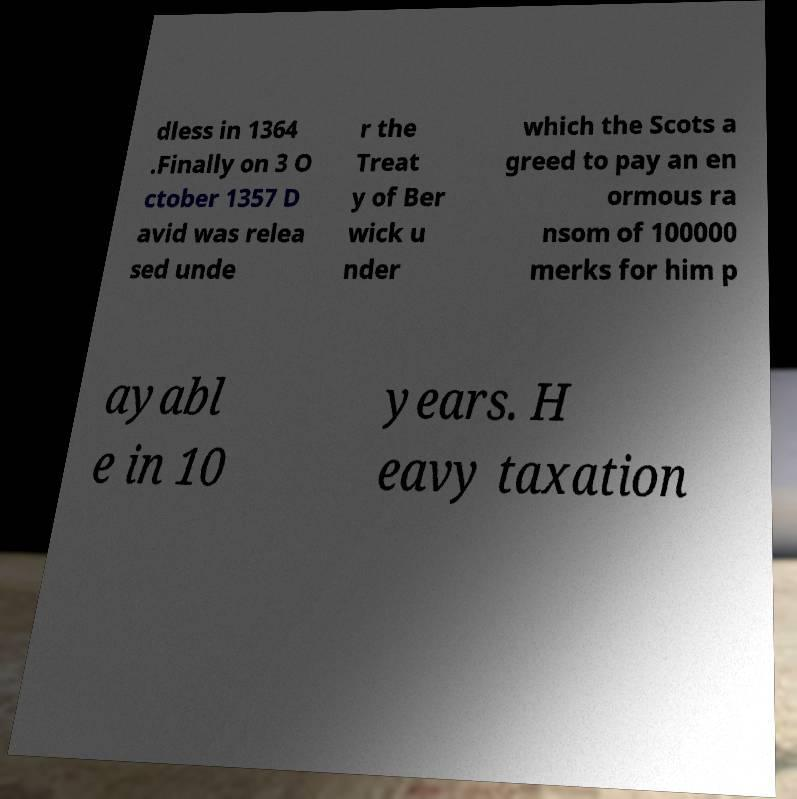Could you assist in decoding the text presented in this image and type it out clearly? dless in 1364 .Finally on 3 O ctober 1357 D avid was relea sed unde r the Treat y of Ber wick u nder which the Scots a greed to pay an en ormous ra nsom of 100000 merks for him p ayabl e in 10 years. H eavy taxation 